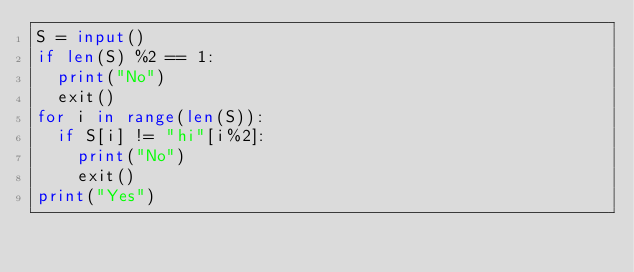Convert code to text. <code><loc_0><loc_0><loc_500><loc_500><_Python_>S = input()
if len(S) %2 == 1:
  print("No")
  exit()
for i in range(len(S)):
  if S[i] != "hi"[i%2]:
    print("No")
    exit()
print("Yes")</code> 